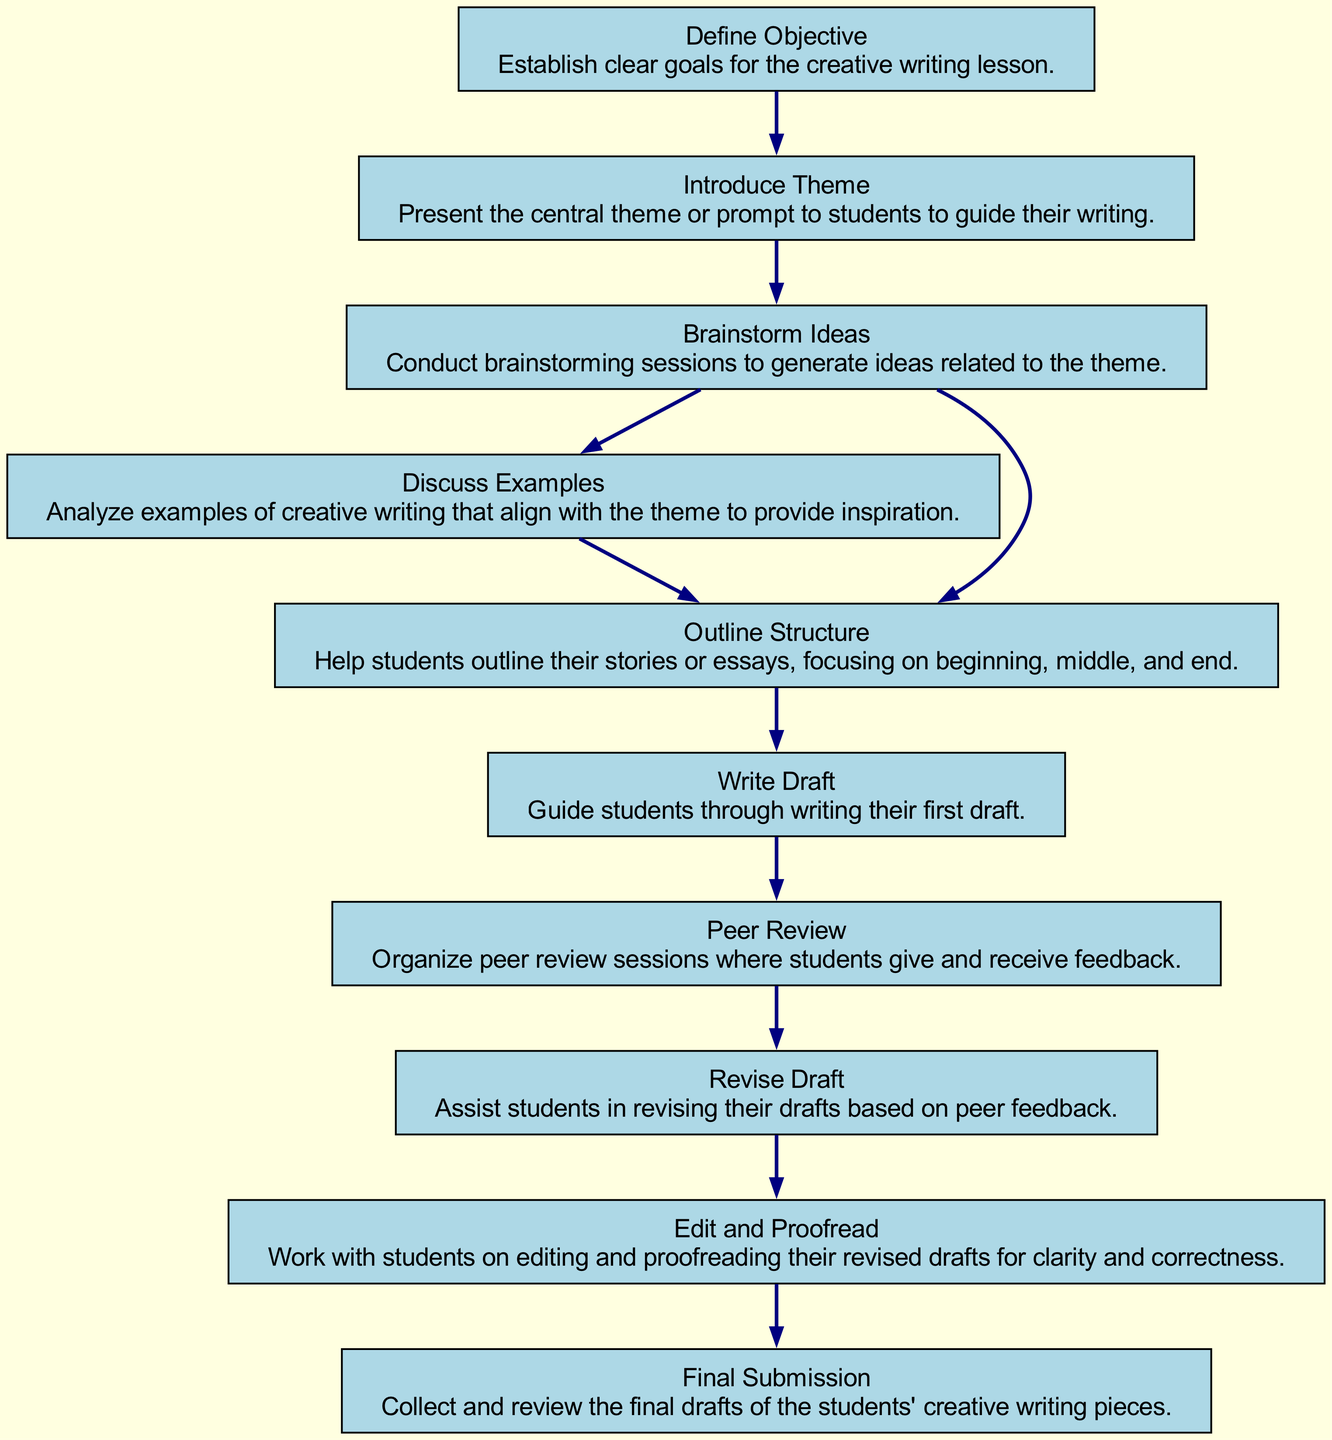What is the first step in the flow chart? The first step in the flow chart is labeled "Define Objective," which establishes the clear goals for the creative writing lesson.
Answer: Define Objective How many nodes are there in the diagram? By counting each distinct step in the flow chart, we can see there are 10 nodes, representing different components of creating an engaging lesson plan.
Answer: 10 What does the "Peer Review" step involve? The "Peer Review" step involves organizing sessions where students give and receive feedback on each other's writing, which is crucial for improving their work.
Answer: Organize peer review sessions How many steps lead to "Revise Draft"? There are two steps that directly lead to "Revise Draft": "Peer Review" and "Discuss Examples."
Answer: 1 What is the final step of the lesson plan? The final step of the lesson plan is "Final Submission," where the teacher collects and reviews the completed drafts of the students' creative writing pieces.
Answer: Final Submission Which two steps can follow "Brainstorm Ideas"? The two steps that can follow "Brainstorm Ideas" are "Discuss Examples" and "Outline Structure," indicating the progression after brainstorming is flexible.
Answer: Discuss Examples and Outline Structure What is the purpose of "Outline Structure"? The purpose of "Outline Structure" is to help students organize their stories or essays, focusing on the essential narrative elements: beginning, middle, and end.
Answer: Help students outline their stories What comes after the "Edit and Proofread" step? After the "Edit and Proofread" step, the next step is "Final Submission," indicating the process leads to submitting the final drafts after careful editing.
Answer: Final Submission Which step follows "Write Draft"? The step that follows "Write Draft" is "Peer Review," as it involves students receiving feedback on the initial drafts they wrote.
Answer: Peer Review What are the two possible next actions after "Brainstorm Ideas"? The two possible next actions after "Brainstorm Ideas" are either moving to "Discuss Examples" or "Outline Structure," showing different paths to progress after brainstorming.
Answer: Discuss Examples or Outline Structure 